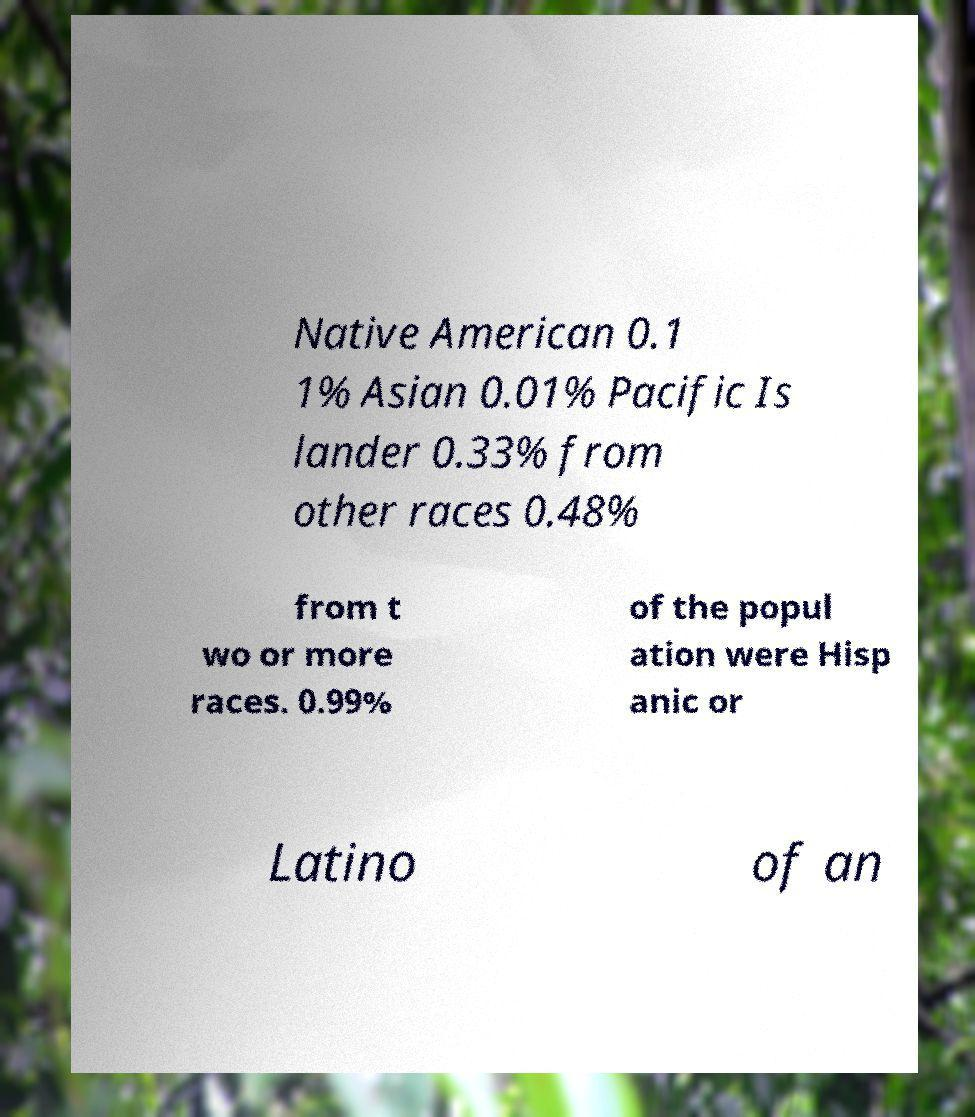For documentation purposes, I need the text within this image transcribed. Could you provide that? Native American 0.1 1% Asian 0.01% Pacific Is lander 0.33% from other races 0.48% from t wo or more races. 0.99% of the popul ation were Hisp anic or Latino of an 